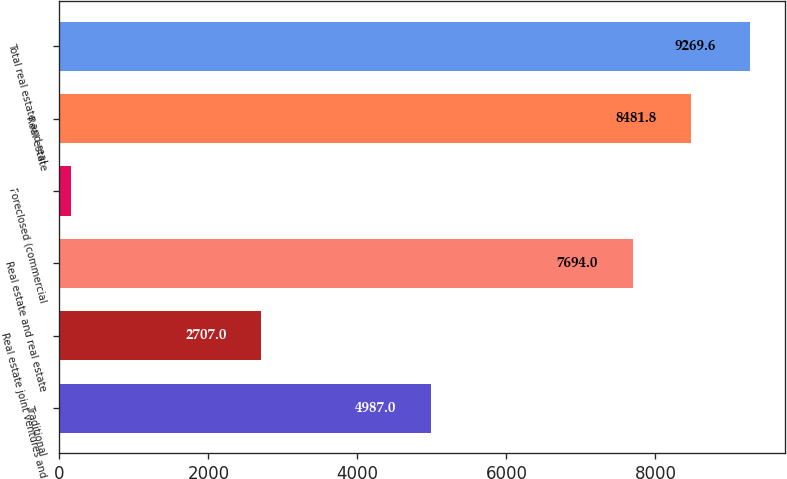Convert chart to OTSL. <chart><loc_0><loc_0><loc_500><loc_500><bar_chart><fcel>Traditional<fcel>Real estate joint ventures and<fcel>Real estate and real estate<fcel>Foreclosed (commercial<fcel>Real estate<fcel>Total real estate and real<nl><fcel>4987<fcel>2707<fcel>7694<fcel>152<fcel>8481.8<fcel>9269.6<nl></chart> 